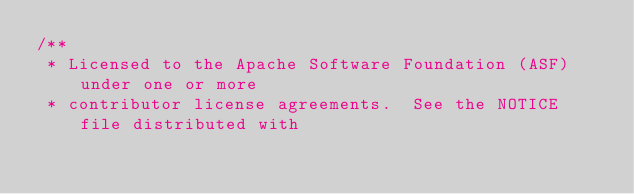Convert code to text. <code><loc_0><loc_0><loc_500><loc_500><_Java_>/**
 * Licensed to the Apache Software Foundation (ASF) under one or more
 * contributor license agreements.  See the NOTICE file distributed with</code> 